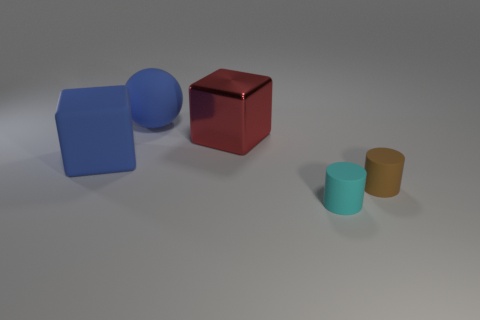Add 4 brown rubber cylinders. How many objects exist? 9 Subtract all balls. How many objects are left? 4 Subtract 2 cylinders. How many cylinders are left? 0 Subtract all big shiny cubes. Subtract all small green rubber balls. How many objects are left? 4 Add 1 small rubber cylinders. How many small rubber cylinders are left? 3 Add 4 blue balls. How many blue balls exist? 5 Subtract 0 purple blocks. How many objects are left? 5 Subtract all brown cubes. Subtract all green spheres. How many cubes are left? 2 